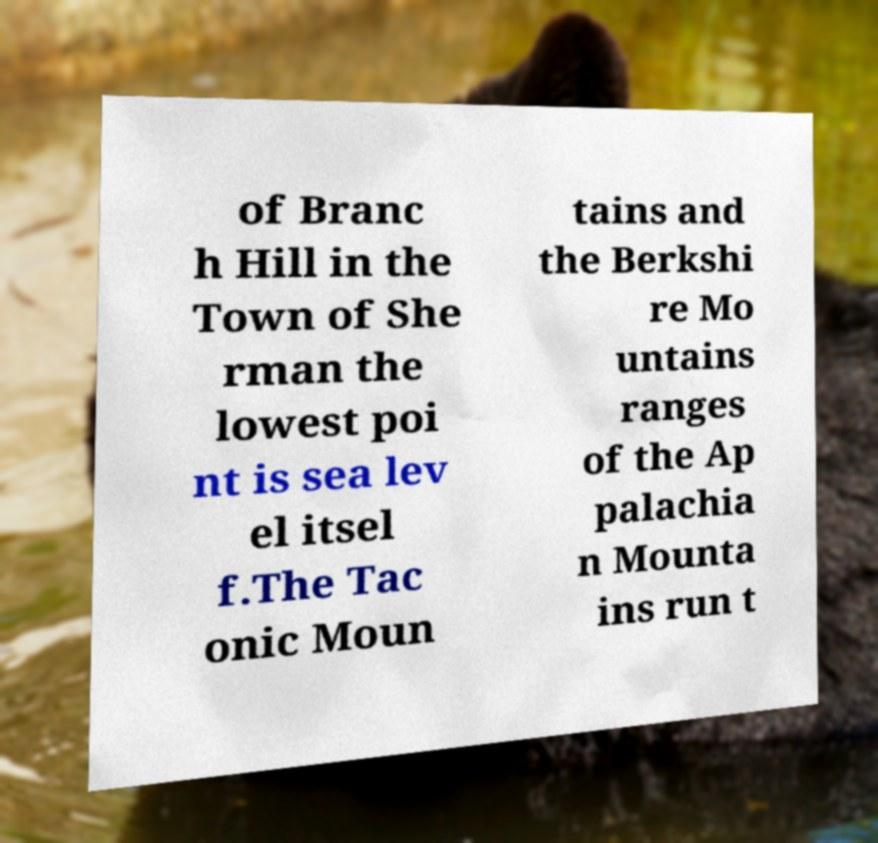Please identify and transcribe the text found in this image. of Branc h Hill in the Town of She rman the lowest poi nt is sea lev el itsel f.The Tac onic Moun tains and the Berkshi re Mo untains ranges of the Ap palachia n Mounta ins run t 